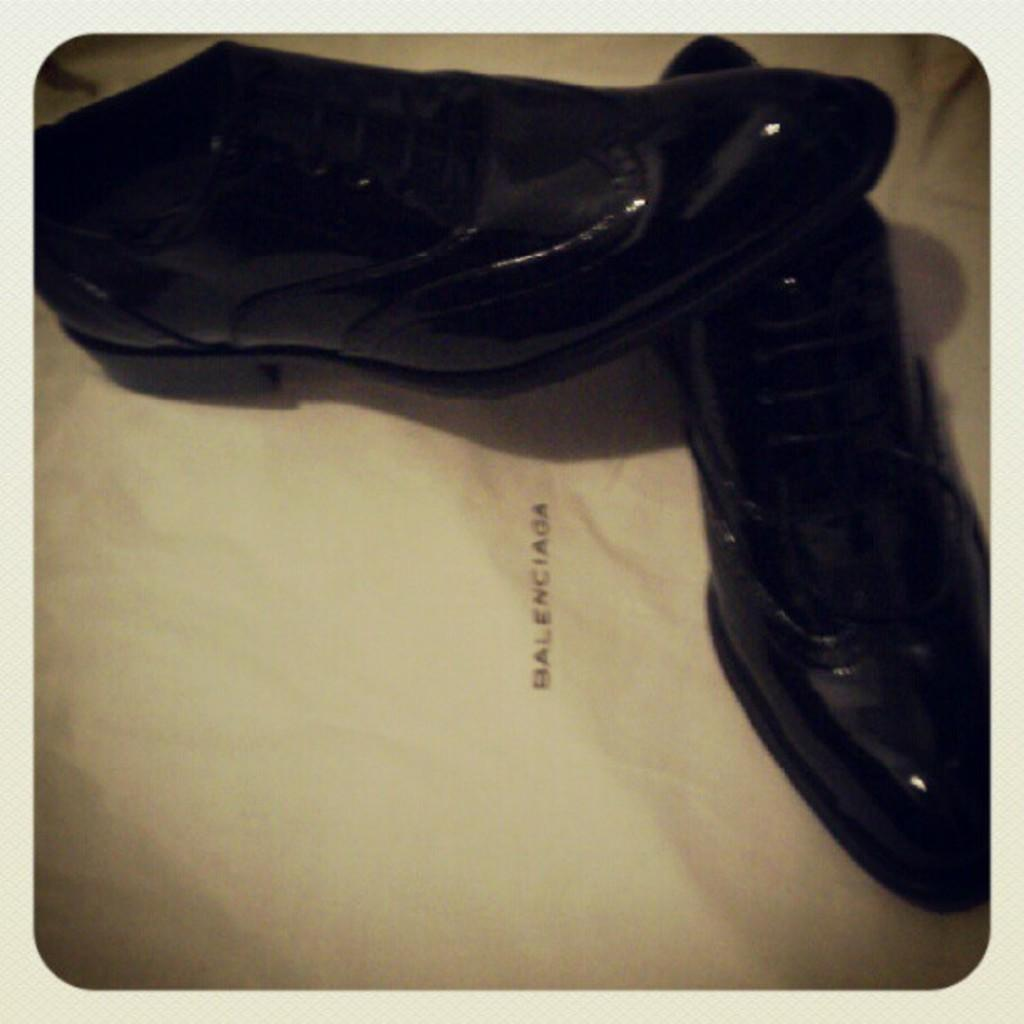What type of objects are in the image? There are shoes in the image. What is the color of the surface on which the shoes are placed? The shoes are on a white surface. What type of patch is visible on the shoes in the image? There is no patch visible on the shoes in the image. How does the snow affect the appearance of the shoes in the image? There is no snow present in the image, so it does not affect the appearance of the shoes. 